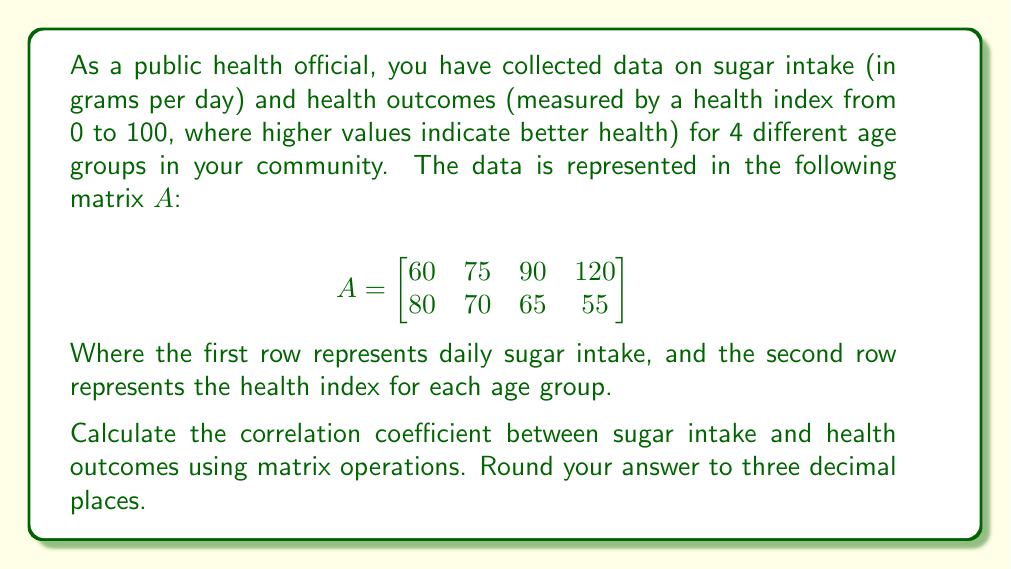What is the answer to this math problem? To calculate the correlation coefficient using matrices, we'll follow these steps:

1) First, we need to center the data by subtracting the mean from each row. Let's calculate the means:

   Sugar intake mean: $\mu_x = (60 + 75 + 90 + 120) / 4 = 86.25$
   Health index mean: $\mu_y = (80 + 70 + 65 + 55) / 4 = 67.5$

2) Now, we create a centered matrix $B$:

   $$B = \begin{bmatrix}
   -26.25 & -11.25 & 3.75 & 33.75 \\
   12.5 & 2.5 & -2.5 & -12.5
   \end{bmatrix}$$

3) The correlation coefficient formula using matrices is:

   $$r = \frac{B B^T}{\sqrt{(BB^T)_{11} (BB^T)_{22}}}$$

   Where $B^T$ is the transpose of $B$, and the subscripts indicate matrix elements.

4) Let's calculate $BB^T$:

   $$BB^T = \begin{bmatrix}
   -26.25 & -11.25 & 3.75 & 33.75 \\
   12.5 & 2.5 & -2.5 & -12.5
   \end{bmatrix} \begin{bmatrix}
   -26.25 & 12.5 \\
   -11.25 & 2.5 \\
   3.75 & -2.5 \\
   33.75 & -12.5
   \end{bmatrix}$$

   $$= \begin{bmatrix}
   2109.375 & -787.5 \\
   -787.5 & 312.5
   \end{bmatrix}$$

5) Now we can calculate the correlation coefficient:

   $$r = \frac{-787.5}{\sqrt{2109.375 \times 312.5}} \approx -0.968$$

6) Rounding to three decimal places, we get -0.968.
Answer: $-0.968$ 